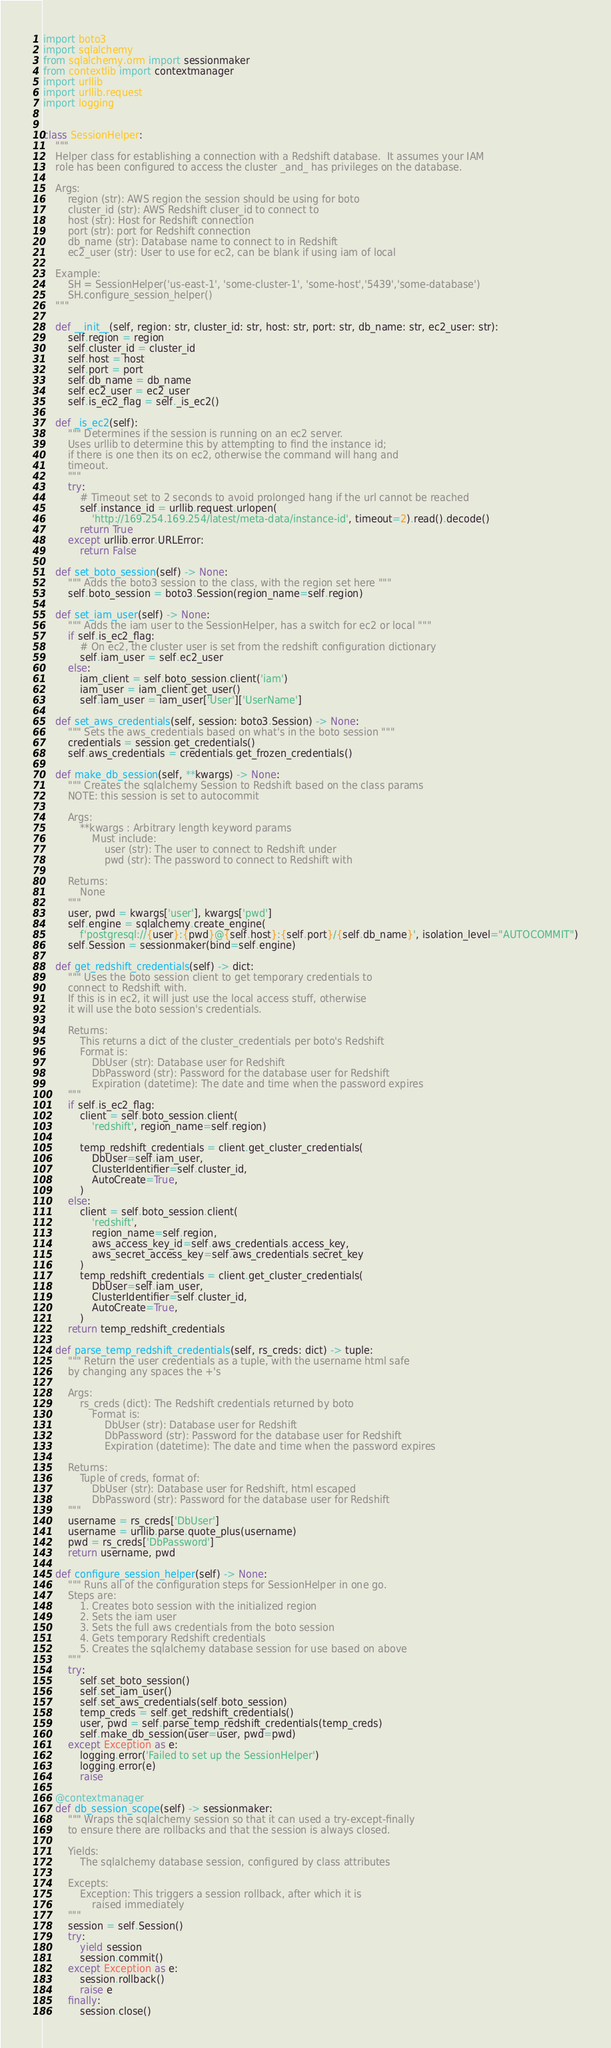<code> <loc_0><loc_0><loc_500><loc_500><_Python_>import boto3
import sqlalchemy
from sqlalchemy.orm import sessionmaker
from contextlib import contextmanager
import urllib
import urllib.request
import logging


class SessionHelper:
    """
    Helper class for establishing a connection with a Redshift database.  It assumes your IAM
    role has been configured to access the cluster _and_ has privileges on the database.

    Args:
        region (str): AWS region the session should be using for boto
        cluster_id (str): AWS Redshift cluser_id to connect to
        host (str): Host for Redshift connection
        port (str): port for Redshift connection
        db_name (str): Database name to connect to in Redshift
        ec2_user (str): User to use for ec2, can be blank if using iam of local

    Example:
        SH = SessionHelper('us-east-1', 'some-cluster-1', 'some-host','5439','some-database')
        SH.configure_session_helper()
    """

    def __init__(self, region: str, cluster_id: str, host: str, port: str, db_name: str, ec2_user: str):
        self.region = region
        self.cluster_id = cluster_id
        self.host = host
        self.port = port
        self.db_name = db_name
        self.ec2_user = ec2_user
        self.is_ec2_flag = self._is_ec2()

    def _is_ec2(self):
        """ Determines if the session is running on an ec2 server.
        Uses urllib to determine this by attempting to find the instance id;
        if there is one then its on ec2, otherwise the command will hang and
        timeout.
        """
        try:
            # Timeout set to 2 seconds to avoid prolonged hang if the url cannot be reached
            self.instance_id = urllib.request.urlopen(
                'http://169.254.169.254/latest/meta-data/instance-id', timeout=2).read().decode()
            return True
        except urllib.error.URLError:
            return False

    def set_boto_session(self) -> None:
        """ Adds the boto3 session to the class, with the region set here """
        self.boto_session = boto3.Session(region_name=self.region)

    def set_iam_user(self) -> None:
        """ Adds the iam user to the SessionHelper, has a switch for ec2 or local """
        if self.is_ec2_flag:
            # On ec2, the cluster user is set from the redshift configuration dictionary
            self.iam_user = self.ec2_user
        else:
            iam_client = self.boto_session.client('iam')
            iam_user = iam_client.get_user()
            self.iam_user = iam_user['User']['UserName']

    def set_aws_credentials(self, session: boto3.Session) -> None:
        """ Sets the aws_credentials based on what's in the boto session """
        credentials = session.get_credentials()
        self.aws_credentials = credentials.get_frozen_credentials()

    def make_db_session(self, **kwargs) -> None:
        """ Creates the sqlalchemy Session to Redshift based on the class params
        NOTE: this session is set to autocommit

        Args:
            **kwargs : Arbitrary length keyword params
                Must include:
                    user (str): The user to connect to Redshift under
                    pwd (str): The password to connect to Redshift with

        Returns:
            None
        """
        user, pwd = kwargs['user'], kwargs['pwd']
        self.engine = sqlalchemy.create_engine(
            f'postgresql://{user}:{pwd}@{self.host}:{self.port}/{self.db_name}', isolation_level="AUTOCOMMIT")
        self.Session = sessionmaker(bind=self.engine)

    def get_redshift_credentials(self) -> dict:
        """ Uses the boto session client to get temporary credentials to
        connect to Redshift with.
        If this is in ec2, it will just use the local access stuff, otherwise
        it will use the boto session's credentials.

        Returns:
            This returns a dict of the cluster_credentials per boto's Redshift
            Format is:
                DbUser (str): Database user for Redshift
                DbPassword (str): Password for the database user for Redshift
                Expiration (datetime): The date and time when the password expires
        """
        if self.is_ec2_flag:
            client = self.boto_session.client(
                'redshift', region_name=self.region)

            temp_redshift_credentials = client.get_cluster_credentials(
                DbUser=self.iam_user,
                ClusterIdentifier=self.cluster_id,
                AutoCreate=True,
            )
        else:
            client = self.boto_session.client(
                'redshift',
                region_name=self.region,
                aws_access_key_id=self.aws_credentials.access_key,
                aws_secret_access_key=self.aws_credentials.secret_key
            )
            temp_redshift_credentials = client.get_cluster_credentials(
                DbUser=self.iam_user,
                ClusterIdentifier=self.cluster_id,
                AutoCreate=True,
            )
        return temp_redshift_credentials

    def parse_temp_redshift_credentials(self, rs_creds: dict) -> tuple:
        """ Return the user credentials as a tuple, with the username html safe
        by changing any spaces the +'s

        Args:
            rs_creds (dict): The Redshift credentials returned by boto
                Format is:
                    DbUser (str): Database user for Redshift
                    DbPassword (str): Password for the database user for Redshift
                    Expiration (datetime): The date and time when the password expires

        Returns:
            Tuple of creds, format of:
                DbUser (str): Database user for Redshift, html escaped
                DbPassword (str): Password for the database user for Redshift
        """
        username = rs_creds['DbUser']
        username = urllib.parse.quote_plus(username)
        pwd = rs_creds['DbPassword']
        return username, pwd

    def configure_session_helper(self) -> None:
        """ Runs all of the configuration steps for SessionHelper in one go.
        Steps are:
            1. Creates boto session with the initialized region
            2. Sets the iam user
            3. Sets the full aws credentials from the boto session
            4. Gets temporary Redshift credentials
            5. Creates the sqlalchemy database session for use based on above
        """
        try:
            self.set_boto_session()
            self.set_iam_user()
            self.set_aws_credentials(self.boto_session)
            temp_creds = self.get_redshift_credentials()
            user, pwd = self.parse_temp_redshift_credentials(temp_creds)
            self.make_db_session(user=user, pwd=pwd)
        except Exception as e:
            logging.error('Failed to set up the SessionHelper')
            logging.error(e)
            raise

    @contextmanager
    def db_session_scope(self) -> sessionmaker:
        """ Wraps the sqlalchemy session so that it can used a try-except-finally
        to ensure there are rollbacks and that the session is always closed.

        Yields:
            The sqlalchemy database session, configured by class attributes

        Excepts:
            Exception: This triggers a session rollback, after which it is
                raised immediately
        """
        session = self.Session()
        try:
            yield session
            session.commit()
        except Exception as e:
            session.rollback()
            raise e
        finally:
            session.close()
</code> 